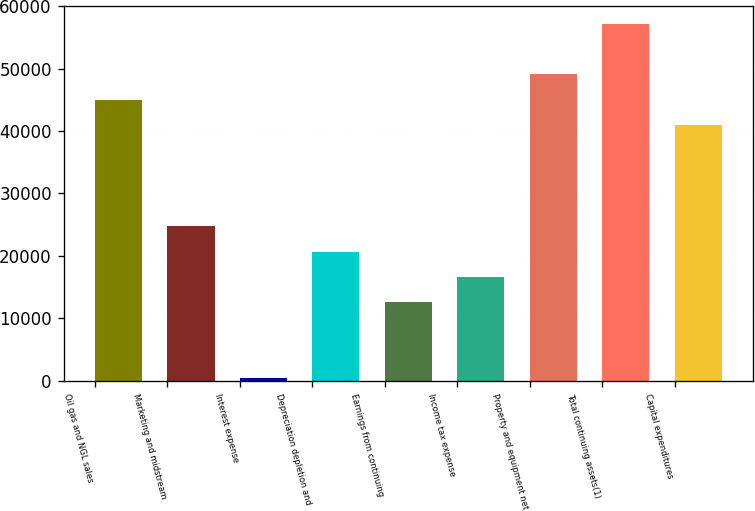Convert chart. <chart><loc_0><loc_0><loc_500><loc_500><bar_chart><fcel>Oil gas and NGL sales<fcel>Marketing and midstream<fcel>Interest expense<fcel>Depreciation depletion and<fcel>Earnings from continuing<fcel>Income tax expense<fcel>Property and equipment net<fcel>Total continuing assets(1)<fcel>Capital expenditures<nl><fcel>45025.2<fcel>24719.2<fcel>352<fcel>20658<fcel>12535.6<fcel>16596.8<fcel>49086.4<fcel>57208.8<fcel>40964<nl></chart> 